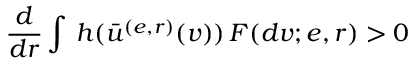Convert formula to latex. <formula><loc_0><loc_0><loc_500><loc_500>\frac { d } { d r } \int \, h ( \bar { u } ^ { ( e , r ) } ( v ) ) \, F ( d v ; e , r ) > 0</formula> 